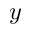Convert formula to latex. <formula><loc_0><loc_0><loc_500><loc_500>y</formula> 